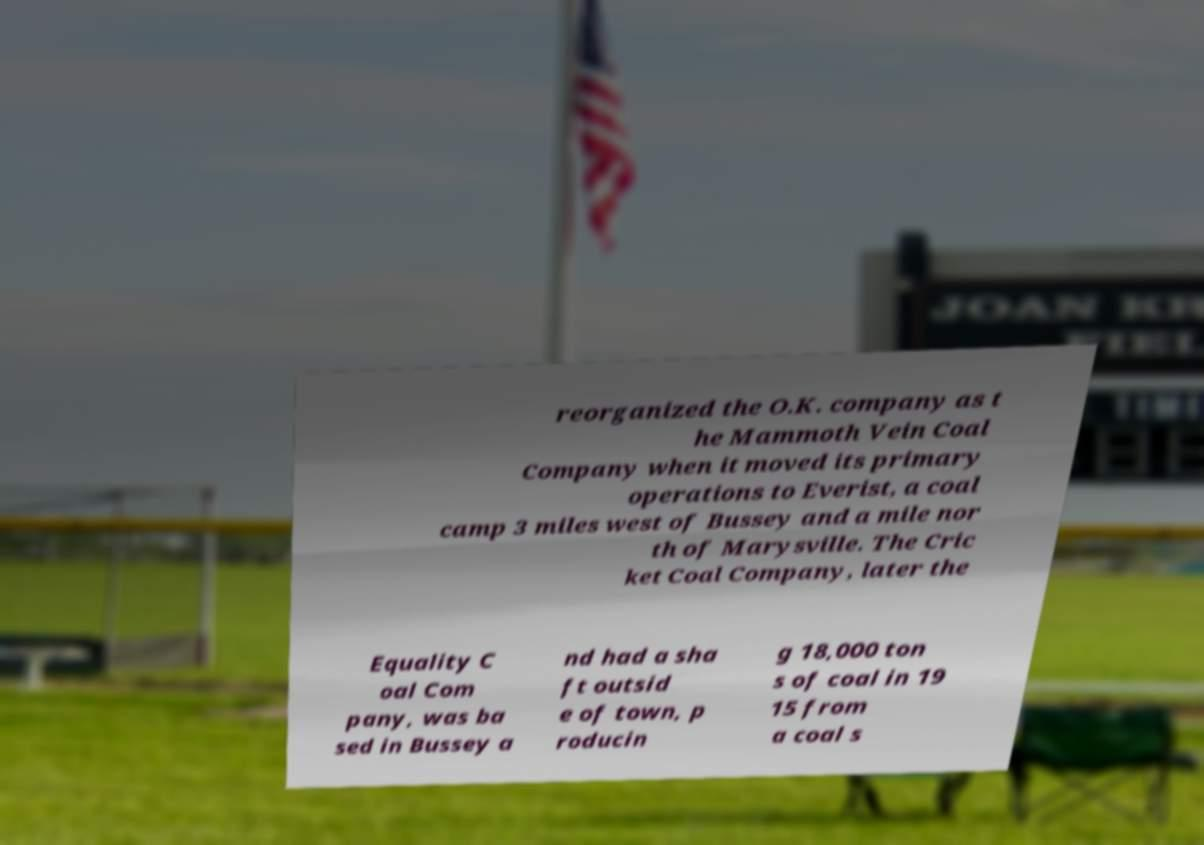Can you accurately transcribe the text from the provided image for me? reorganized the O.K. company as t he Mammoth Vein Coal Company when it moved its primary operations to Everist, a coal camp 3 miles west of Bussey and a mile nor th of Marysville. The Cric ket Coal Company, later the Equality C oal Com pany, was ba sed in Bussey a nd had a sha ft outsid e of town, p roducin g 18,000 ton s of coal in 19 15 from a coal s 